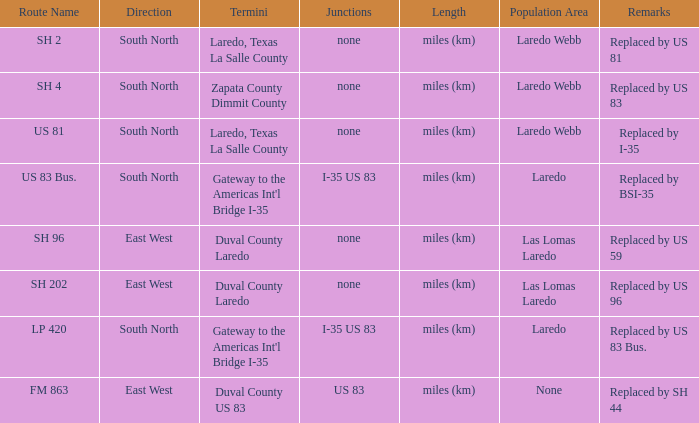What are the demographic areas where "replaced by us 83" can be found in their notes section? Laredo Webb. 